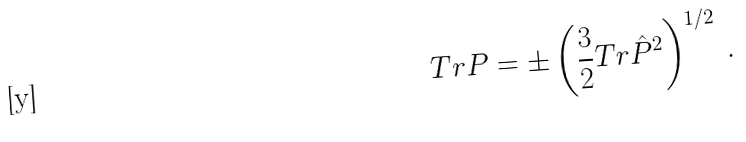Convert formula to latex. <formula><loc_0><loc_0><loc_500><loc_500>T r P = \pm \left ( \frac { 3 } { 2 } T r \hat { P } ^ { 2 } \right ) ^ { 1 / 2 } \, .</formula> 